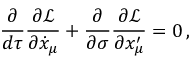Convert formula to latex. <formula><loc_0><loc_0><loc_500><loc_500>\frac { \partial } { d \tau } \frac { \partial \mathcal { L } } { \partial \dot { x } _ { \mu } } + \frac { \partial } { \partial \sigma } \frac { \partial \mathcal { L } } { \partial x _ { \mu } ^ { \prime } } = 0 \, ,</formula> 